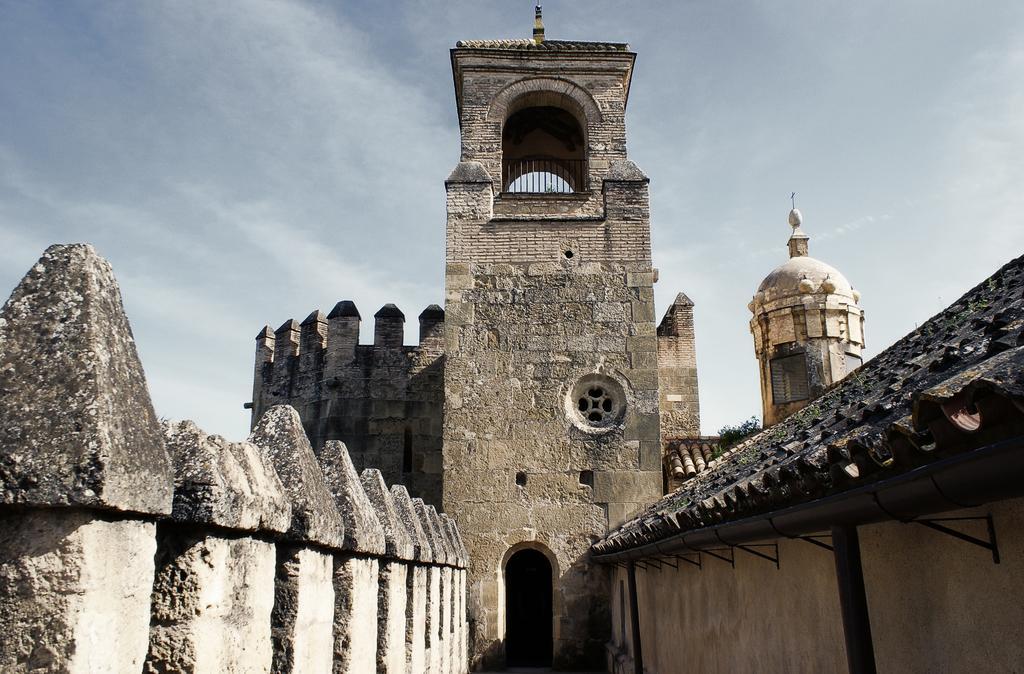Could you give a brief overview of what you see in this image? In this picture we can see a fort, and we can find clouds. 